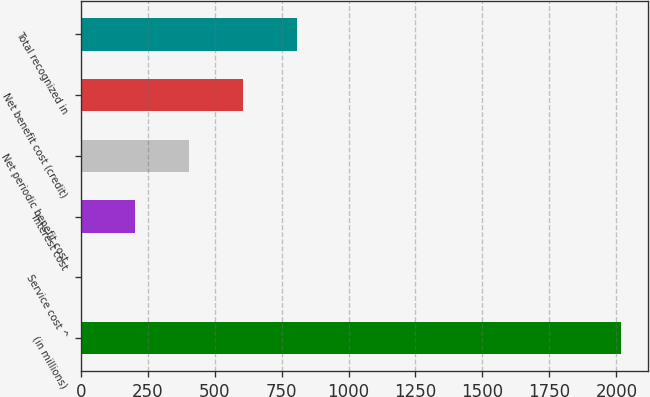Convert chart. <chart><loc_0><loc_0><loc_500><loc_500><bar_chart><fcel>(in millions)<fcel>Service cost ^<fcel>Interest cost<fcel>Net periodic benefit cost<fcel>Net benefit cost (credit)<fcel>Total recognized in<nl><fcel>2018<fcel>1<fcel>202.7<fcel>404.4<fcel>606.1<fcel>807.8<nl></chart> 